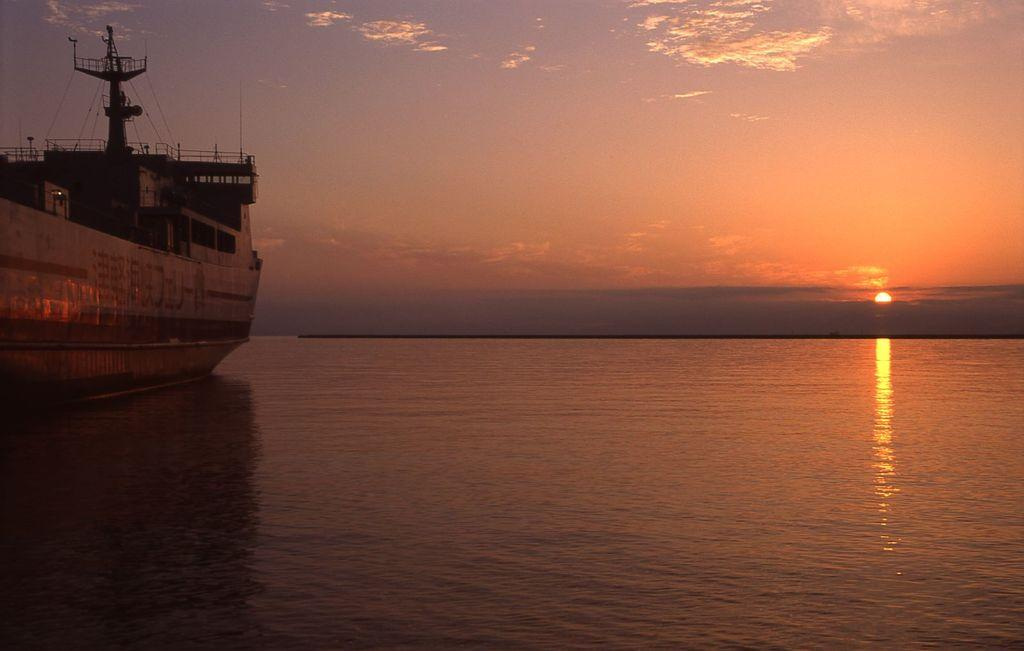What is the main subject of the image? The main subject of the image is a ship in the water. What is the ship located in? The ship is located in the water. What can be seen in the background of the image? The sky is visible in the background of the image. What celestial body is observable in the sky? The sun is observable in the sky. What type of weather can be inferred from the image? The presence of clouds in the sky suggests that the weather might be partly cloudy. What type of hat is being worn by the letters in the image? There are no letters or hats present in the image; it features a ship in the water with a visible sky. 